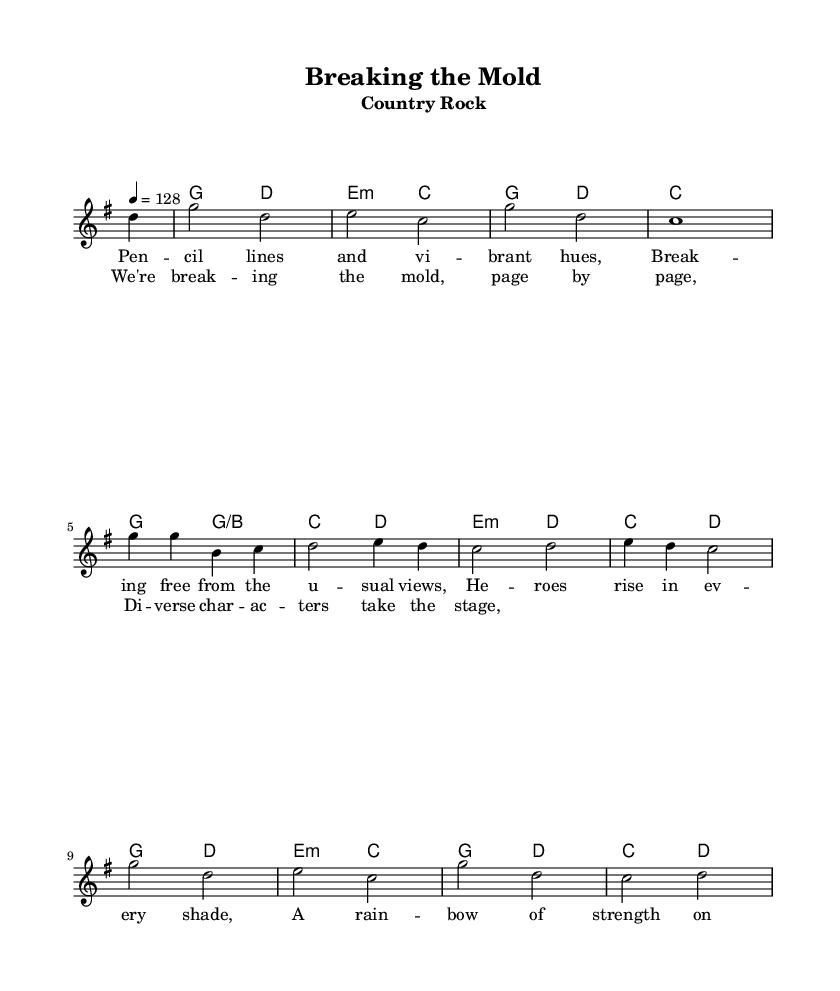What is the key signature of this music? The key signature is G major, which has one sharp (F#). This can be identified by the initial marking at the beginning of the staff where the key is denoted.
Answer: G major What is the time signature of the piece? The time signature is 4/4, as indicated by the notation at the beginning of the score. This means there are four beats in each measure, and each quarter note gets one beat.
Answer: 4/4 What is the tempo marking for this piece? The tempo marking is quarter note = 128, which is indicated at the start of the music. This suggests a moderately fast pace for the performance.
Answer: 128 How many measures are in the verse? The verse consists of 4 measures, as observed from the melody line and the corresponding lyrics. Counting the spaces between the vertical bar lines shows a total of four sections of music.
Answer: 4 What chord follows the D chord in the harmonies? The chord that follows the D chord is E minor, as seen in the chord progression notated beside the melody. It is the next harmony indicated after the D chord in the sequence.
Answer: E minor What is the thematic focus of the lyrics? The thematic focus is on diversity and breaking stereotypes in comic book characters. This is evident from the lyrics discussing heroes in every shade and breaking free from usual views.
Answer: Diversity How many times is the chorus repeated in the score? The chorus is indicated to be repeated twice throughout the score, which can be deduced by examining the lyrics sections marked in the music.
Answer: Twice 